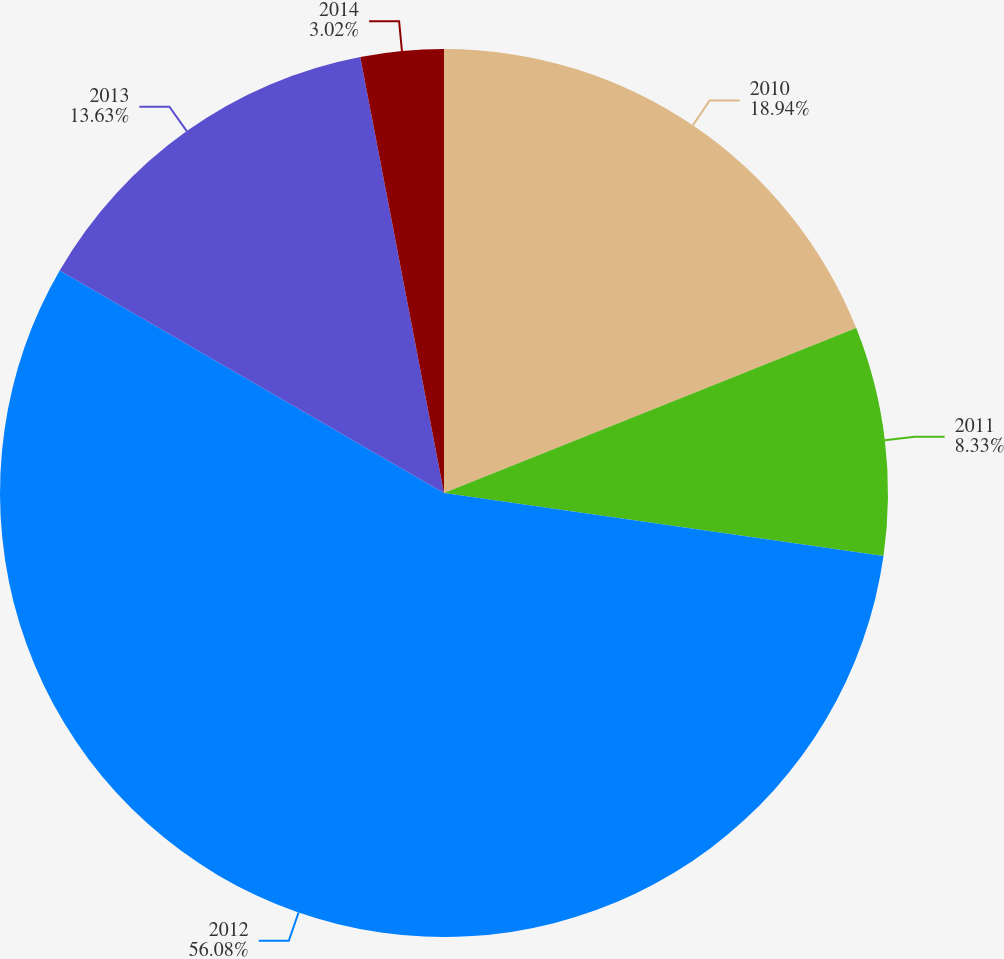<chart> <loc_0><loc_0><loc_500><loc_500><pie_chart><fcel>2010<fcel>2011<fcel>2012<fcel>2013<fcel>2014<nl><fcel>18.94%<fcel>8.33%<fcel>56.08%<fcel>13.63%<fcel>3.02%<nl></chart> 